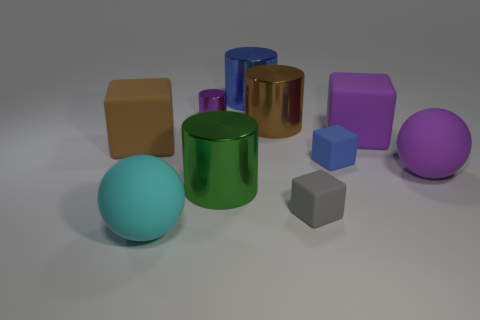Which object appears to be in the foreground and why? The pale blue sphere is in the foreground, primarily because it is the largest object in the bottom left of the image and appears closer to the viewer due to its size and positioning. Its placement and proportional size make it visually dominant, which draws the eye and makes it stand out as the foremost element. 